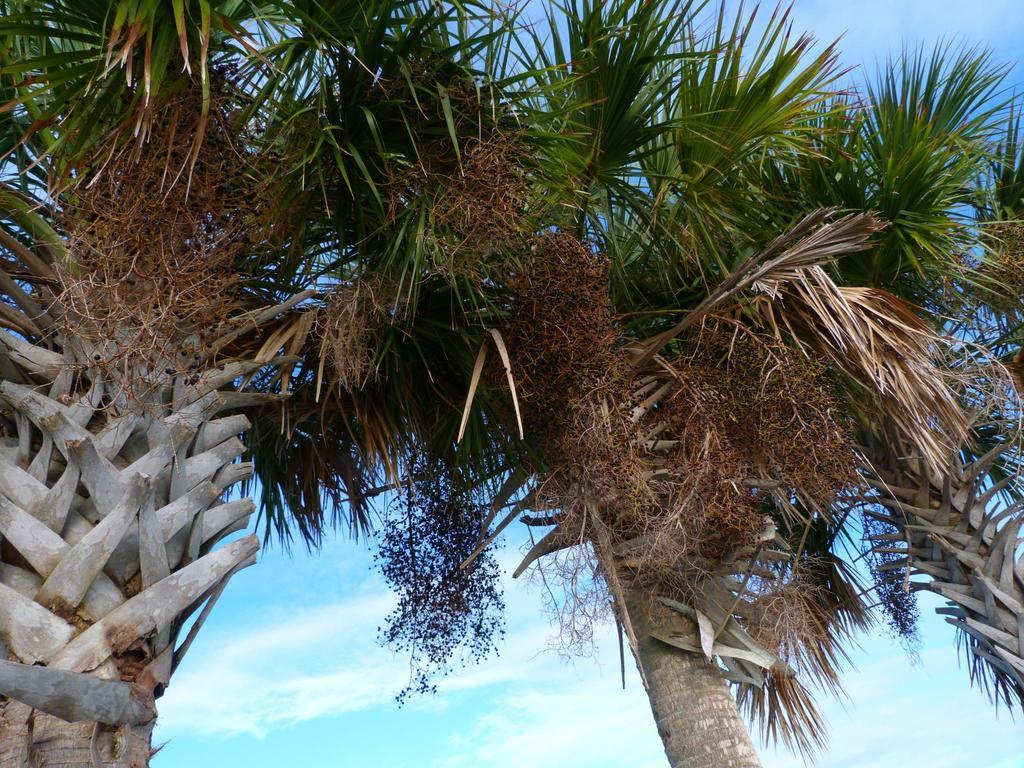Could you give a brief overview of what you see in this image? In the image we can see there are trees and there is a cloudy sky. 